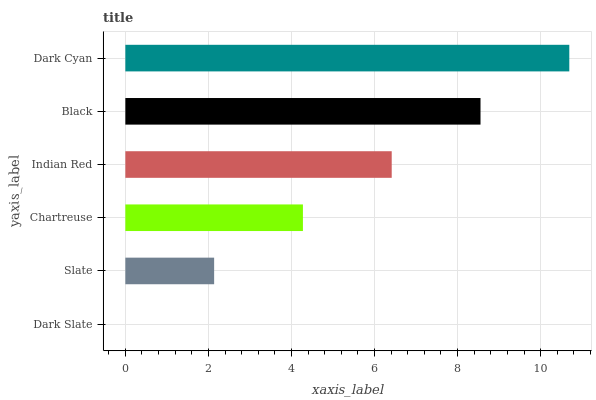Is Dark Slate the minimum?
Answer yes or no. Yes. Is Dark Cyan the maximum?
Answer yes or no. Yes. Is Slate the minimum?
Answer yes or no. No. Is Slate the maximum?
Answer yes or no. No. Is Slate greater than Dark Slate?
Answer yes or no. Yes. Is Dark Slate less than Slate?
Answer yes or no. Yes. Is Dark Slate greater than Slate?
Answer yes or no. No. Is Slate less than Dark Slate?
Answer yes or no. No. Is Indian Red the high median?
Answer yes or no. Yes. Is Chartreuse the low median?
Answer yes or no. Yes. Is Dark Cyan the high median?
Answer yes or no. No. Is Indian Red the low median?
Answer yes or no. No. 